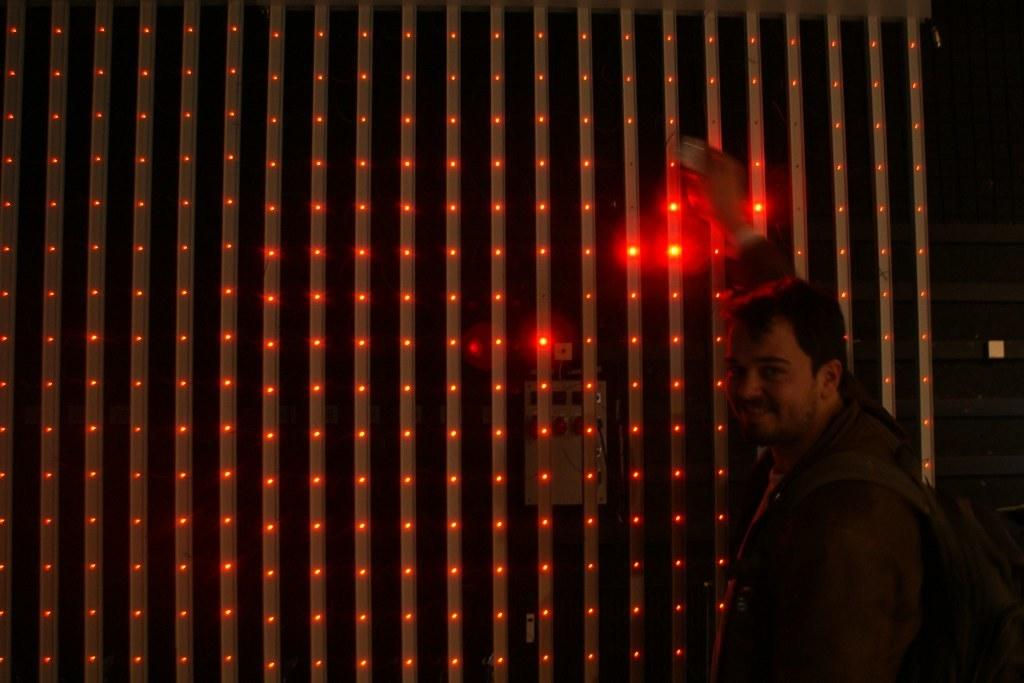Who is present in the image? There is a man in the image. What is the man's facial expression? The man is smiling. What is the man wearing in the image? The man is wearing a bag. What can be seen in the background of the image? There are red lights in the background of the image. What type of oatmeal is the man eating in the image? There is no oatmeal present in the image, and the man is not eating anything. Can you describe the bee that is buzzing around the man in the image? There is no bee present in the image; the man is the only person visible. 